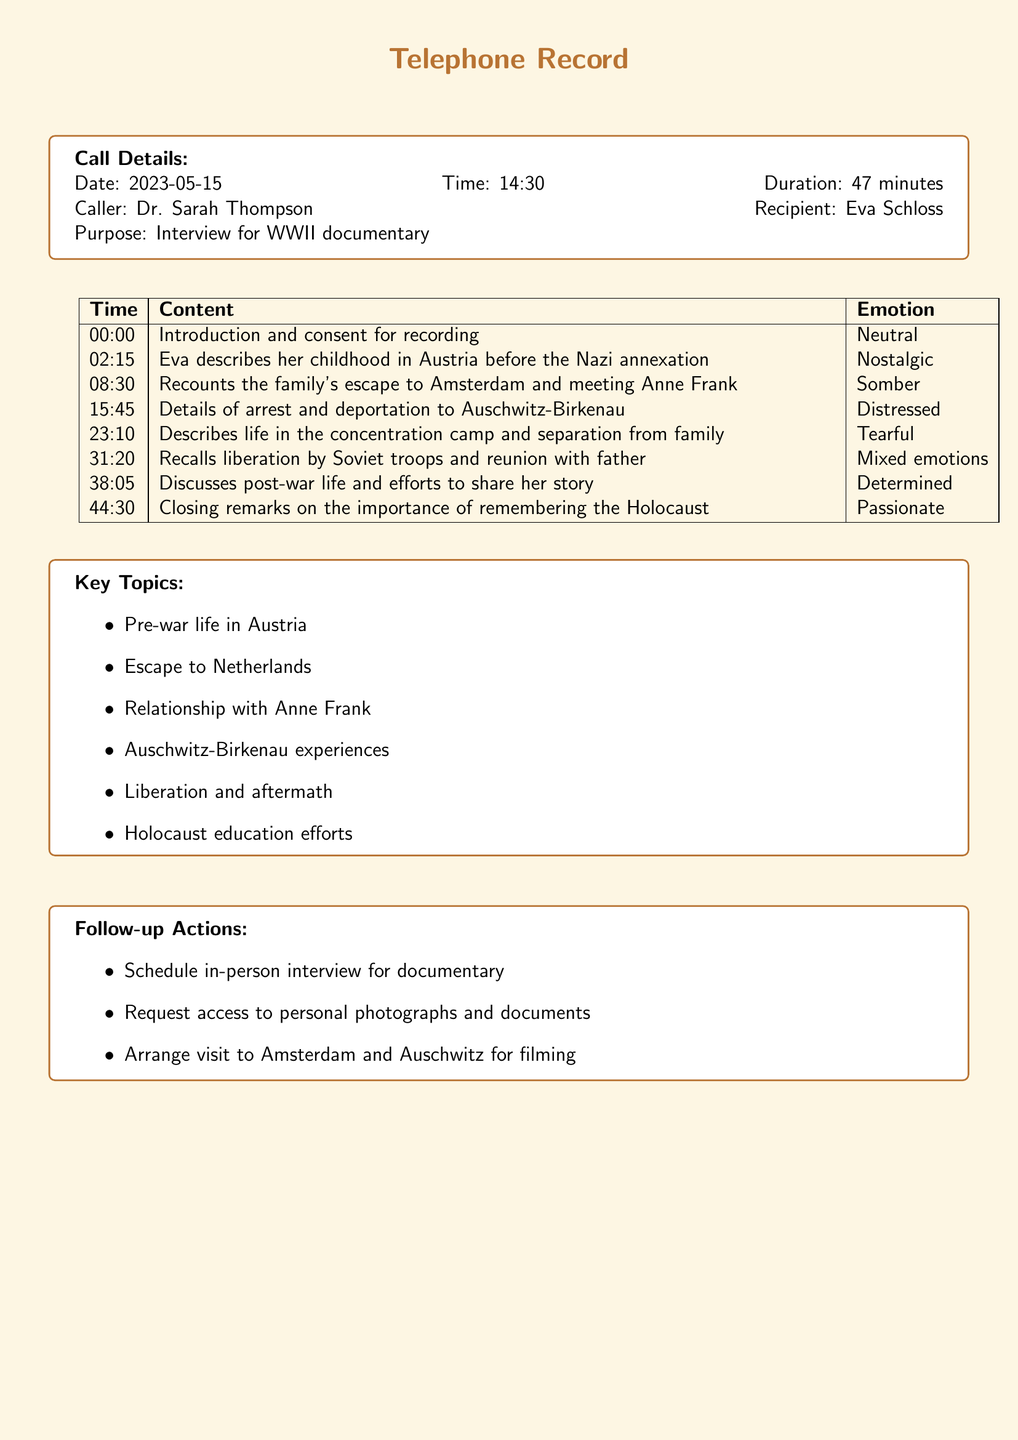What is the date of the call? The date is explicitly mentioned in the call details section of the document.
Answer: 2023-05-15 Who is the caller? The caller's name is stated in the call details, indicating who initiated the conversation.
Answer: Dr. Sarah Thompson What was the duration of the call? The total length of the call is listed in the details, showing how long the conversation lasted.
Answer: 47 minutes At what time did the call occur? The time of the call is provided in the call details section and specifies when the conversation took place.
Answer: 14:30 What topic does Eva Schloss describe at 31:20? The content discussed at that specific timestamp is recorded in relation to her experiences, indicating her emotional state.
Answer: Liberation by Soviet troops and reunion with father What emotion is associated with Eva’s memories of her childhood? The emotional tone associated with her childhood memories provides insight into her feelings during that part of the conversation.
Answer: Nostalgic What is the purpose of the call? The purpose is clearly stated in the call details, summarizing why the call took place and its significance.
Answer: Interview for WWII documentary What is one follow-up action mentioned in the document? The document lists several actions to take after the call, highlighting important steps moving forward.
Answer: Schedule in-person interview for documentary What key theme is covered concerning Auschwitz-Birkenau experiences? The theme listed in the key topics section summarizes the main focus of that part of the conversation.
Answer: Auschwitz-Birkenau experiences What emotion is expressed during the discussion about post-war life? The emotional tone specified during this phase of the conversation indicates how she felt about life after the war.
Answer: Determined 